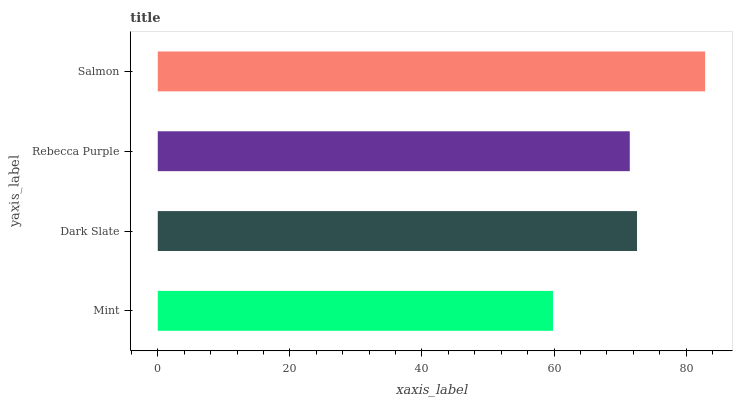Is Mint the minimum?
Answer yes or no. Yes. Is Salmon the maximum?
Answer yes or no. Yes. Is Dark Slate the minimum?
Answer yes or no. No. Is Dark Slate the maximum?
Answer yes or no. No. Is Dark Slate greater than Mint?
Answer yes or no. Yes. Is Mint less than Dark Slate?
Answer yes or no. Yes. Is Mint greater than Dark Slate?
Answer yes or no. No. Is Dark Slate less than Mint?
Answer yes or no. No. Is Dark Slate the high median?
Answer yes or no. Yes. Is Rebecca Purple the low median?
Answer yes or no. Yes. Is Rebecca Purple the high median?
Answer yes or no. No. Is Mint the low median?
Answer yes or no. No. 